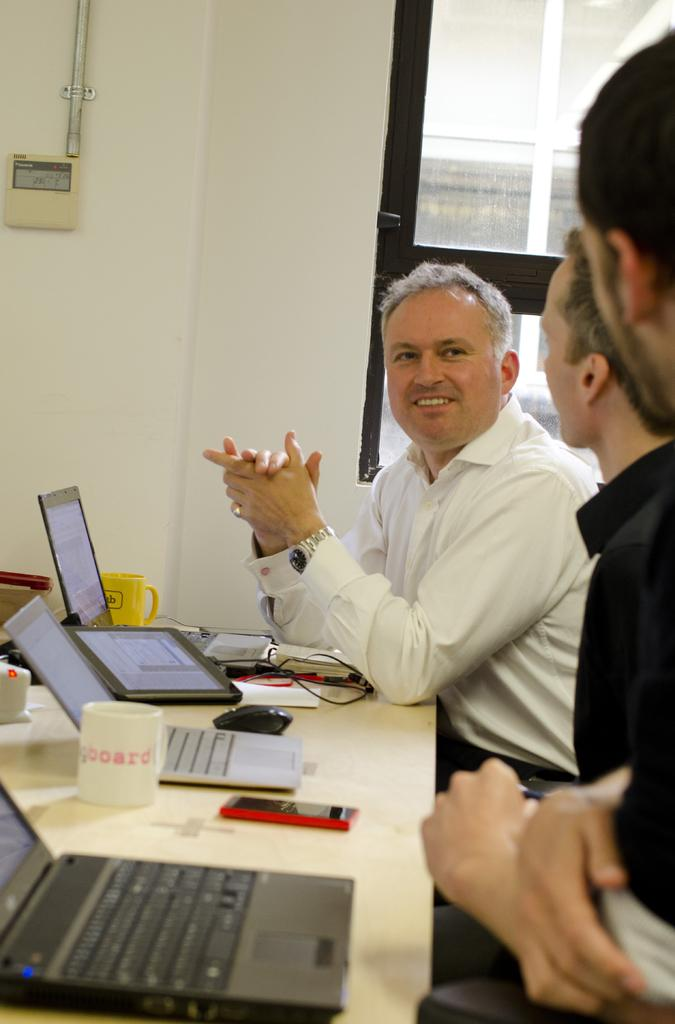Provide a one-sentence caption for the provided image. Man giving a talk to two other people with a cup that says "board" in front of them. 